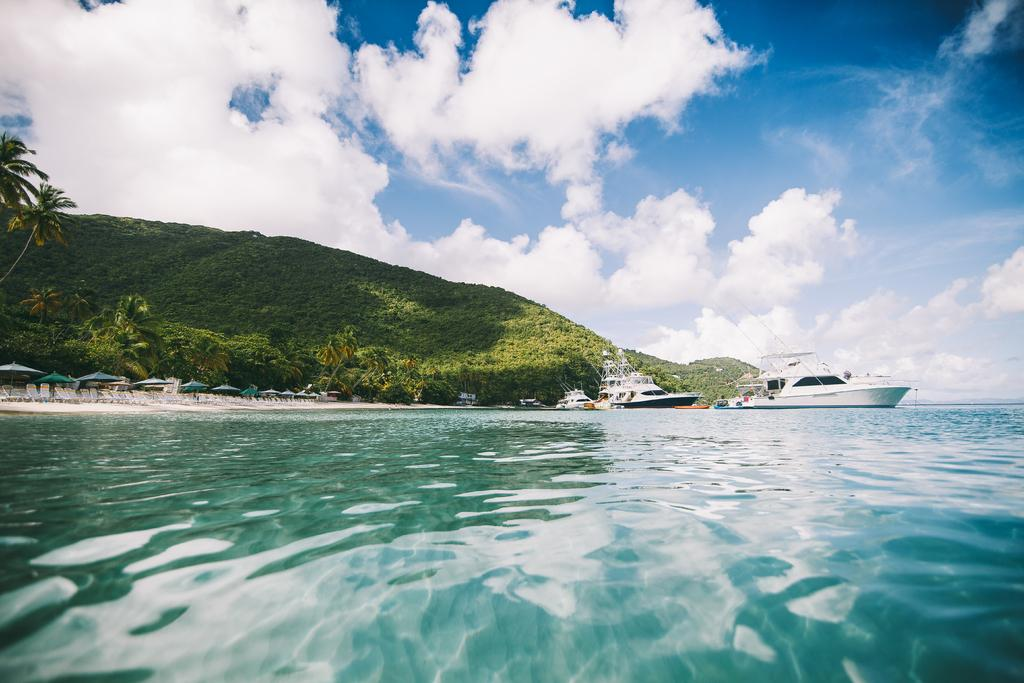What type of vehicles can be seen on the water in the image? There are ships on the water in the image. What objects are present for shade or protection from the sun? Umbrellas are present in the image. What type of furniture is visible in the image? Chairs are visible in the image. What type of vegetation is present in the image? Trees are in the image. What is visible in the background of the image? The sky is visible in the background of the image. What can be observed in the sky? Clouds are present in the sky. How does the beginner operate the pump in the image? There is no pump present in the image, so it is not possible to answer that question. 